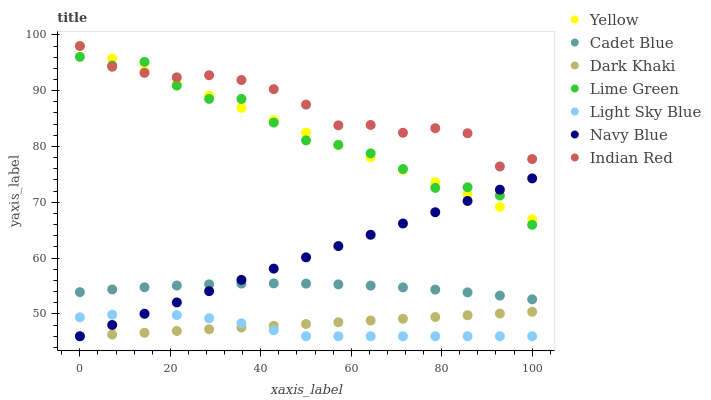Does Light Sky Blue have the minimum area under the curve?
Answer yes or no. Yes. Does Indian Red have the maximum area under the curve?
Answer yes or no. Yes. Does Navy Blue have the minimum area under the curve?
Answer yes or no. No. Does Navy Blue have the maximum area under the curve?
Answer yes or no. No. Is Yellow the smoothest?
Answer yes or no. Yes. Is Lime Green the roughest?
Answer yes or no. Yes. Is Navy Blue the smoothest?
Answer yes or no. No. Is Navy Blue the roughest?
Answer yes or no. No. Does Navy Blue have the lowest value?
Answer yes or no. Yes. Does Yellow have the lowest value?
Answer yes or no. No. Does Indian Red have the highest value?
Answer yes or no. Yes. Does Navy Blue have the highest value?
Answer yes or no. No. Is Light Sky Blue less than Cadet Blue?
Answer yes or no. Yes. Is Cadet Blue greater than Light Sky Blue?
Answer yes or no. Yes. Does Lime Green intersect Yellow?
Answer yes or no. Yes. Is Lime Green less than Yellow?
Answer yes or no. No. Is Lime Green greater than Yellow?
Answer yes or no. No. Does Light Sky Blue intersect Cadet Blue?
Answer yes or no. No. 